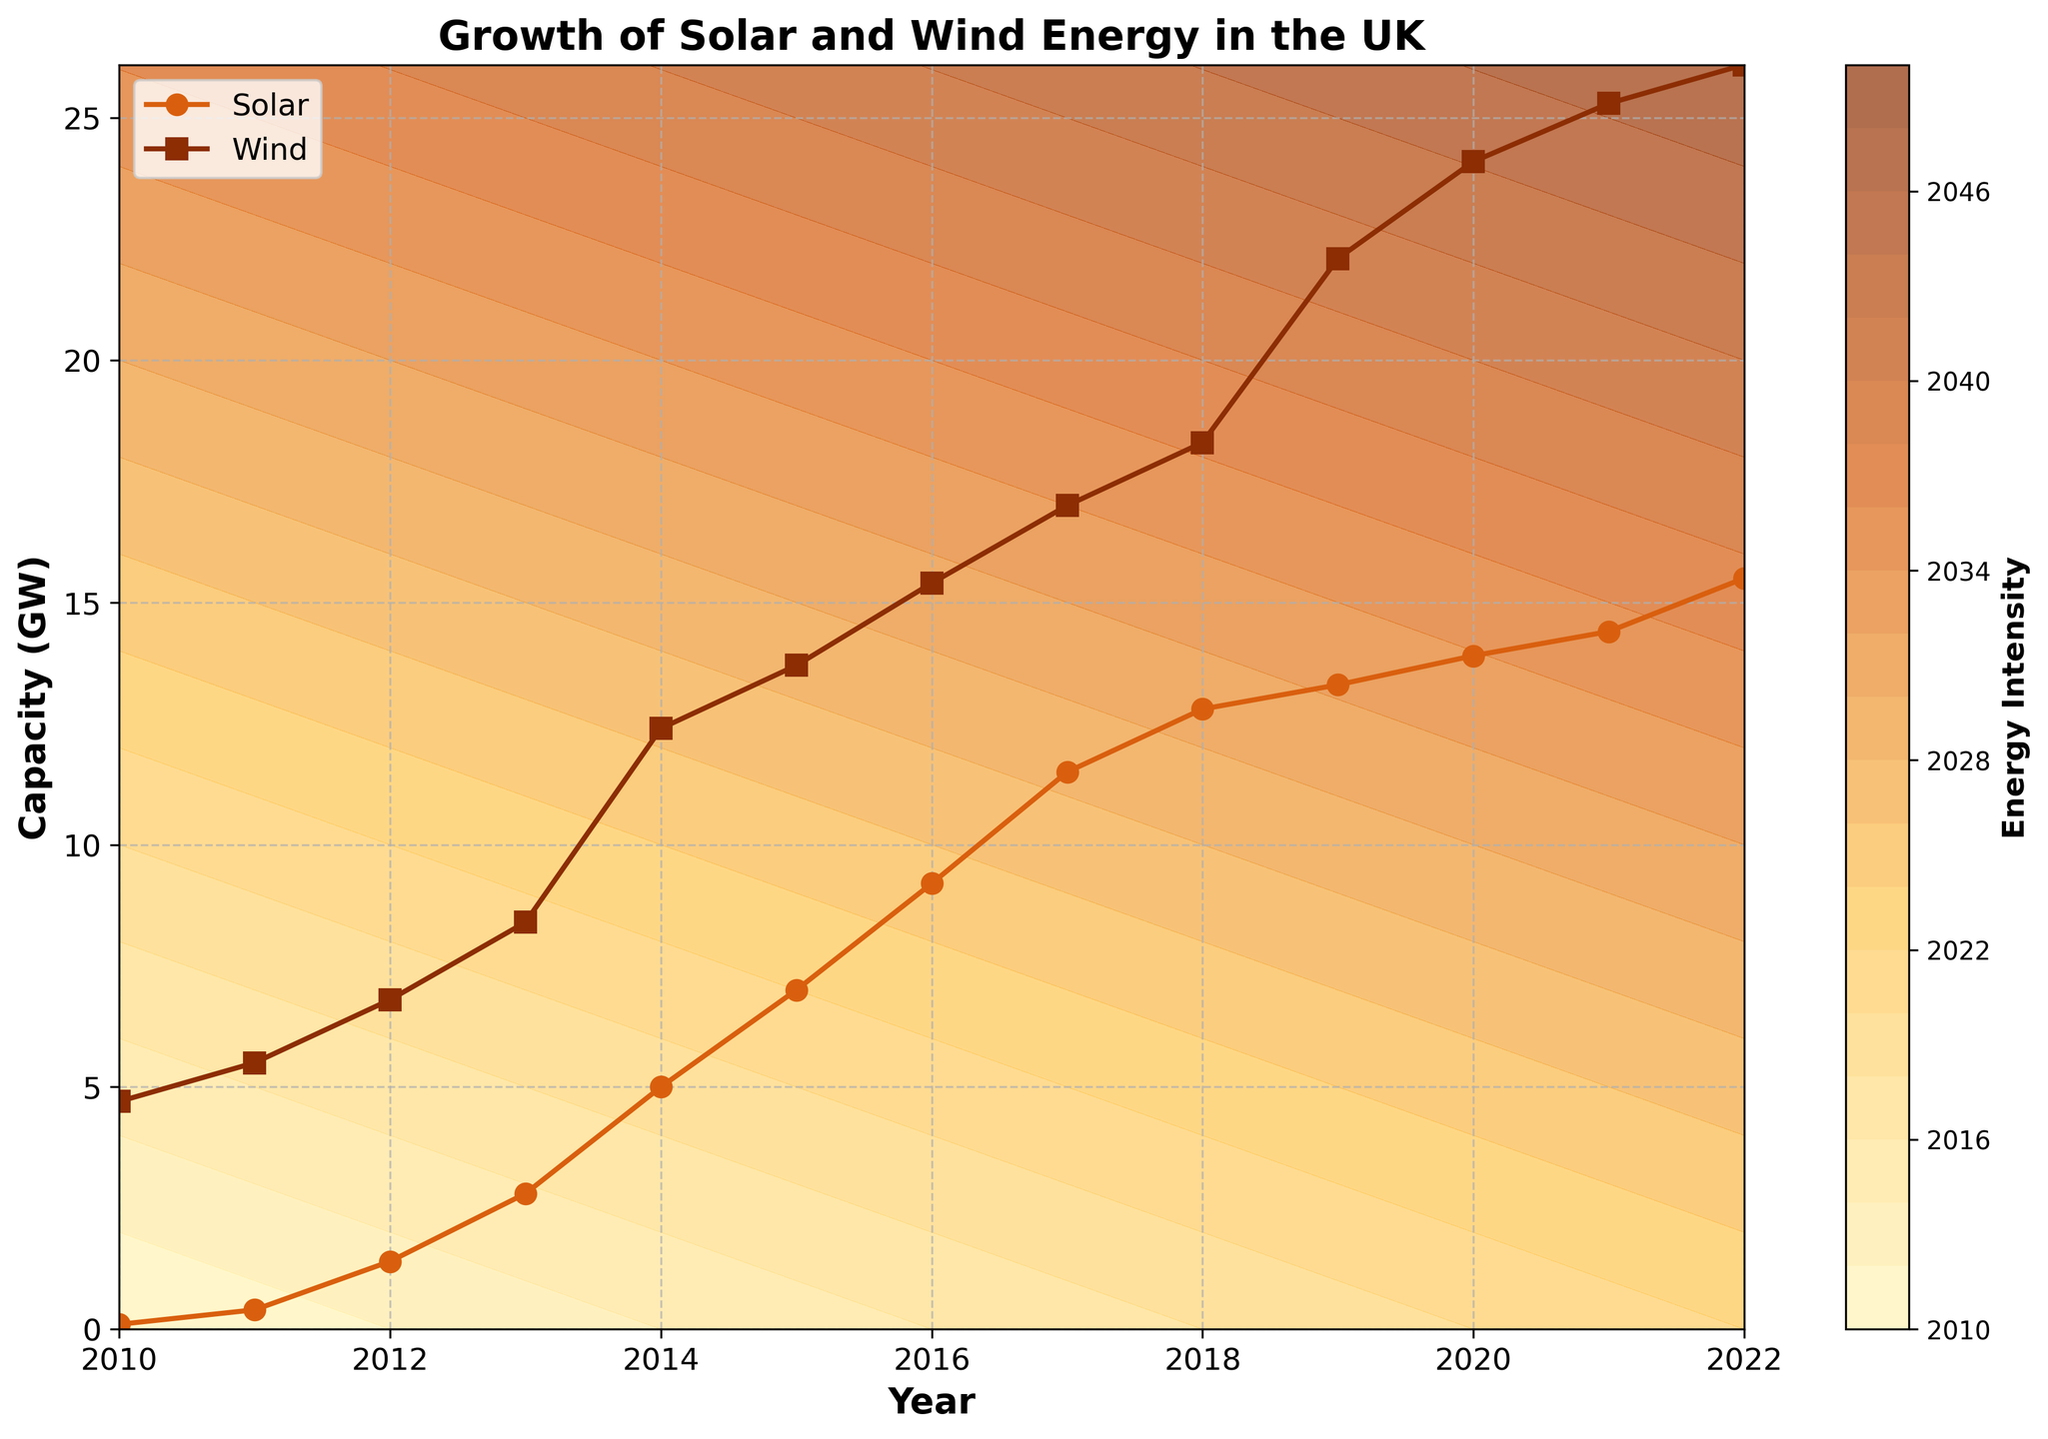What is the title of the figure? The title is written prominently at the top of the figure. It summarizes the main topic of the plot, which can be directly read.
Answer: Growth of Solar and Wind Energy in the UK What do the x-axis and y-axis represent? The x-axis label shows "Year," and the y-axis label shows "Capacity (GW)." This indicates that the horizontal axis represents the timeline, while the vertical axis measures the energy capacity in gigawatts.
Answer: Year and Capacity (GW) Which renewable source had a higher capacity in 2015, Solar or Wind? By looking at the data points for the year 2015 on the figure, we can see that Wind has a higher capacity than Solar. The Wind capacity is marked by the squares, while the Solar capacity is marked by the circles.
Answer: Wind How did the Solar energy capacity change between 2010 and 2015? To determine the change, you locate the Solar data points for 2010 and 2015. The capacity in 2010 is around 0.1 GW, and in 2015, it is about 7 GW. Subtracting the two values gives the change.
Answer: Increased by 6.9 GW During which year did Wind energy have its steepest increase in capacity? Observing the points and lines for Wind energy (squares) each year, the steepest increase occurs where the upward slope is sharpest. Between 2018 and 2019, there is a sharp increase from about 18.3 GW to 22.1 GW.
Answer: 2019 At what capacity level does the color transition from yellowish to reddish on the contour plot? The contour plot uses a gradient of colors, transitioning from yellowish to reddish shades. By observing the color transitions and the labels on the contour lines, the transition appears around higher intensity levels closer to the top-right section of the plot.
Answer: Around 20 GW Compare the growth rates of Solar and Wind energy between 2017 and 2022. Which grew faster? Comparing the growth from 2017 to 2022 for both sources: Solar went from 11.5 GW to 15.5 GW, and Wind went from 17 GW to 26.1 GW. Solar's growth rate = (15.5-11.5)/11.5 = ~34.78%, Wind's growth rate = (26.1-17)/17 = ~53.53%. Wind grew faster.
Answer: Wind What capacity does the color bar label as "Energy Intensity"? The color bar beside the contour plot represents different capacity levels. The label "Energy Intensity" refers to varying levels of combined energy capacity shown on the plot. The exact maximum value at the top of the color bar is around the highest values of the energy capacity mentioned, which can be read from the increments and the ranges on the color bar.
Answer: 40 GW How does the contour plot visually indicate areas of high energy intensity? The areas of high energy intensity on a contour plot are shown by darker and more intense colors; in this case, reddish shades represent higher energy intensities. The labels on these contours can also help identify the exact energy levels.
Answer: Reddish areas Is there a year when both Solar and Wind capacities appear to stabilize or grow at a slower rate? Examining the lines for both renewable sources, a stabilization or slower growth period is when the lines are less steep. After 2020, the Wind and Solar capacities grow at a slower rate, showing less steep lines until 2022.
Answer: 2020-2022 